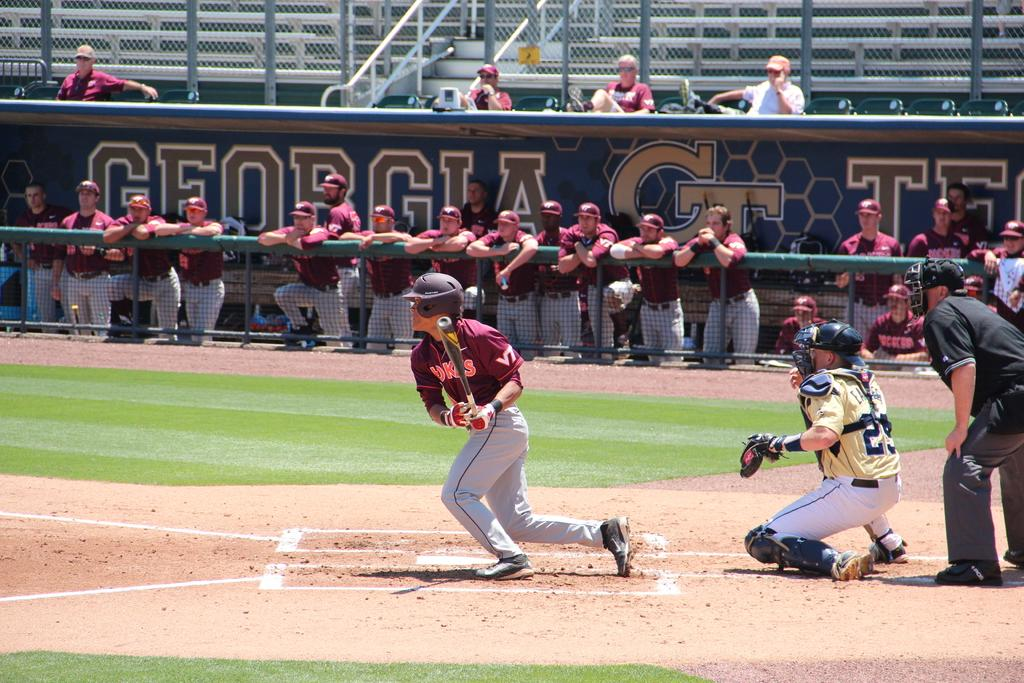<image>
Present a compact description of the photo's key features. College baseball game Georgia Tech against the Hawks. 